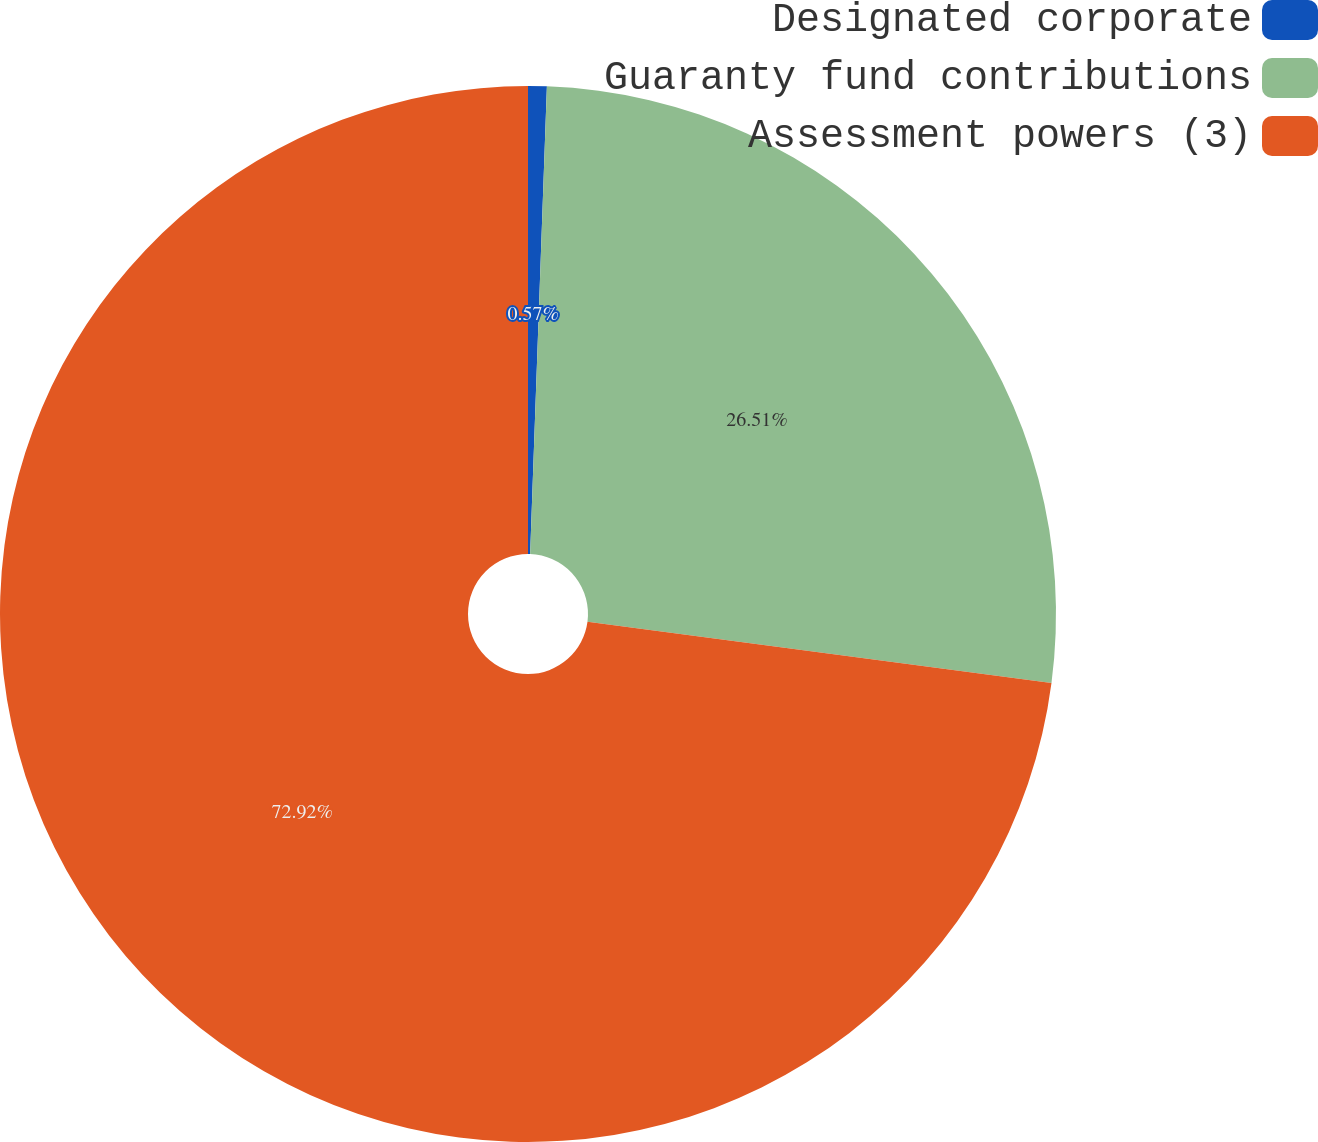Convert chart to OTSL. <chart><loc_0><loc_0><loc_500><loc_500><pie_chart><fcel>Designated corporate<fcel>Guaranty fund contributions<fcel>Assessment powers (3)<nl><fcel>0.57%<fcel>26.51%<fcel>72.91%<nl></chart> 